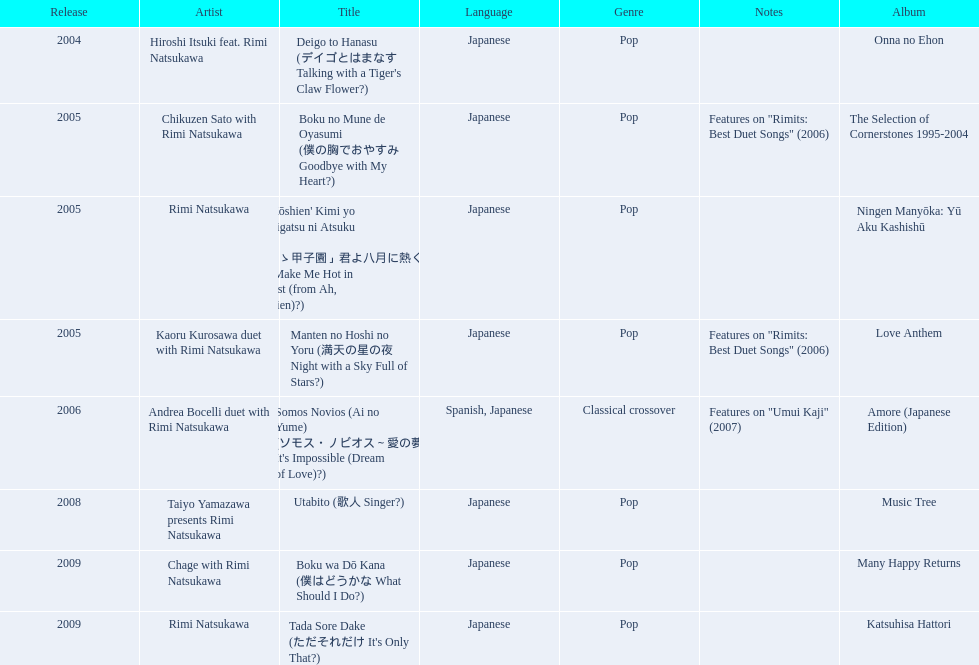What are all of the titles? Deigo to Hanasu (デイゴとはまなす Talking with a Tiger's Claw Flower?), Boku no Mune de Oyasumi (僕の胸でおやすみ Goodbye with My Heart?), 'Aa Kōshien' Kimi yo Hachigatsu ni Atsuku Nare (「あゝ甲子園」君よ八月に熱くなれ You Make Me Hot in August (from Ah, Kōshien)?), Manten no Hoshi no Yoru (満天の星の夜 Night with a Sky Full of Stars?), Somos Novios (Ai no Yume) (ソモス・ノビオス～愛の夢 It's Impossible (Dream of Love)?), Utabito (歌人 Singer?), Boku wa Dō Kana (僕はどうかな What Should I Do?), Tada Sore Dake (ただそれだけ It's Only That?). What are their notes? , Features on "Rimits: Best Duet Songs" (2006), , Features on "Rimits: Best Duet Songs" (2006), Features on "Umui Kaji" (2007), , , . Which title shares its notes with manten no hoshi no yoru (man tian noxing noye night with a sky full of stars?)? Boku no Mune de Oyasumi (僕の胸でおやすみ Goodbye with My Heart?). 